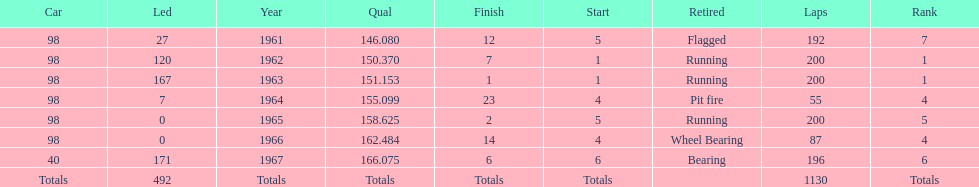What is the most common cause for a retired car? Running. 